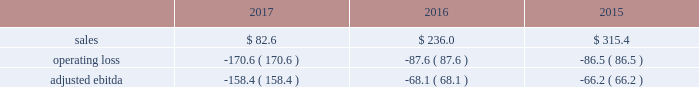2016 vs .
2015 sales of $ 498.8 increased $ 212.1 , or 74% ( 74 % ) .
The increase in sales was driven by the jazan project which more than offset the decrease in small equipment and other air separation unit sales .
In 2016 , we recognized approximately $ 300 of sales related to the jazan project .
Operating loss of $ 21.3 decreased 59% ( 59 % ) , or $ 30.3 , primarily from income on the jazan project and benefits from cost reduction actions , partially offset by lower other sale of equipment project activity and a gain associated with the cancellation of a sale of equipment contract that was recorded in fiscal year 2015 .
Corporate and other the corporate and other segment includes two ongoing global businesses ( our lng equipment business and our liquid helium and liquid hydrogen transport and storage container businesses ) , and corporate support functions that benefit all the segments .
Corporate and other also includes income and expense that is not directly associated with the business segments , including foreign exchange gains and losses and stranded costs .
Stranded costs result from functional support previously provided to the two divisions comprising the former materials technologies segment .
The majority of these costs are reimbursed to air products pursuant to short-term transition services agreements under which air products provides transition services to versum for emd and to evonik for pmd .
The reimbursement for costs in support of the transition services has been reflected on the consolidated income statements within "other income ( expense ) , net." .
2017 vs .
2016 sales of $ 82.6 decreased $ 153.4 , primarily due to lower lng project activity .
We expect continued weakness in new lng project orders due to continued oversupply of lng in the market .
Operating loss of $ 170.6 increased $ 83.0 due to lower lng activity , partially offset by productivity improvements and income from transition service agreements with versum and evonik .
2016 vs .
2015 sales of $ 236.0 decreased $ 79.4 , or 25% ( 25 % ) , primarily due to lower lng sale of equipment activity .
Operating loss of $ 87.6 increased 1% ( 1 % ) , or $ 1.1 , due to lower lng activity , mostly offset by benefits from our recent cost reduction actions and lower foreign exchange losses .
Reconciliation of non-gaap financial measures ( millions of dollars unless otherwise indicated , except for per share data ) the company has presented certain financial measures on a non-gaap ( 201cadjusted 201d ) basis and has provided a reconciliation to the most directly comparable financial measure calculated in accordance with gaap .
These financial measures are not meant to be considered in isolation or as a substitute for the most directly comparable financial measure calculated in accordance with gaap .
The company believes these non-gaap measures provide investors , potential investors , securities analysts , and others with useful supplemental information to evaluate the performance of the business because such measures , when viewed together with our financial results computed in accordance with gaap , provide a more complete understanding of the factors and trends affecting our historical financial performance and projected future results .
In many cases , our non-gaap measures are determined by adjusting the most directly comparable gaap financial measure to exclude certain disclosed items ( 201cnon-gaap adjustments 201d ) that we believe are not representative of the underlying business performance .
For example , air products has executed its strategic plan to restructure the company to focus on its core industrial gases business .
This resulted in significant cost reduction and asset actions that we believe are important for investors to understand separately from the performance of the underlying business .
The reader should be aware that we may incur similar expenses in the future .
The tax impact of our non- gaap adjustments reflects the expected current and deferred income tax expense impact of the transactions and is impacted primarily by the statutory tax rate of the various relevant jurisdictions and the taxability of the adjustments in those jurisdictions .
Investors should also consider the limitations associated with these non-gaap measures , including the potential lack of comparability of these measures from one company to another. .
Considering the years 2015-2017 , what is the highest adjusted ebitda observed? 
Rationale: it is the maximum value of adjusted ebitda during these years .
Computations: table_max(adjusted ebitda, none)
Answer: -66.2. 